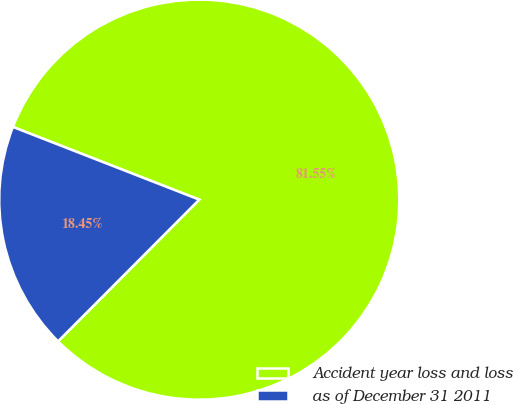<chart> <loc_0><loc_0><loc_500><loc_500><pie_chart><fcel>Accident year loss and loss<fcel>as of December 31 2011<nl><fcel>81.55%<fcel>18.45%<nl></chart> 